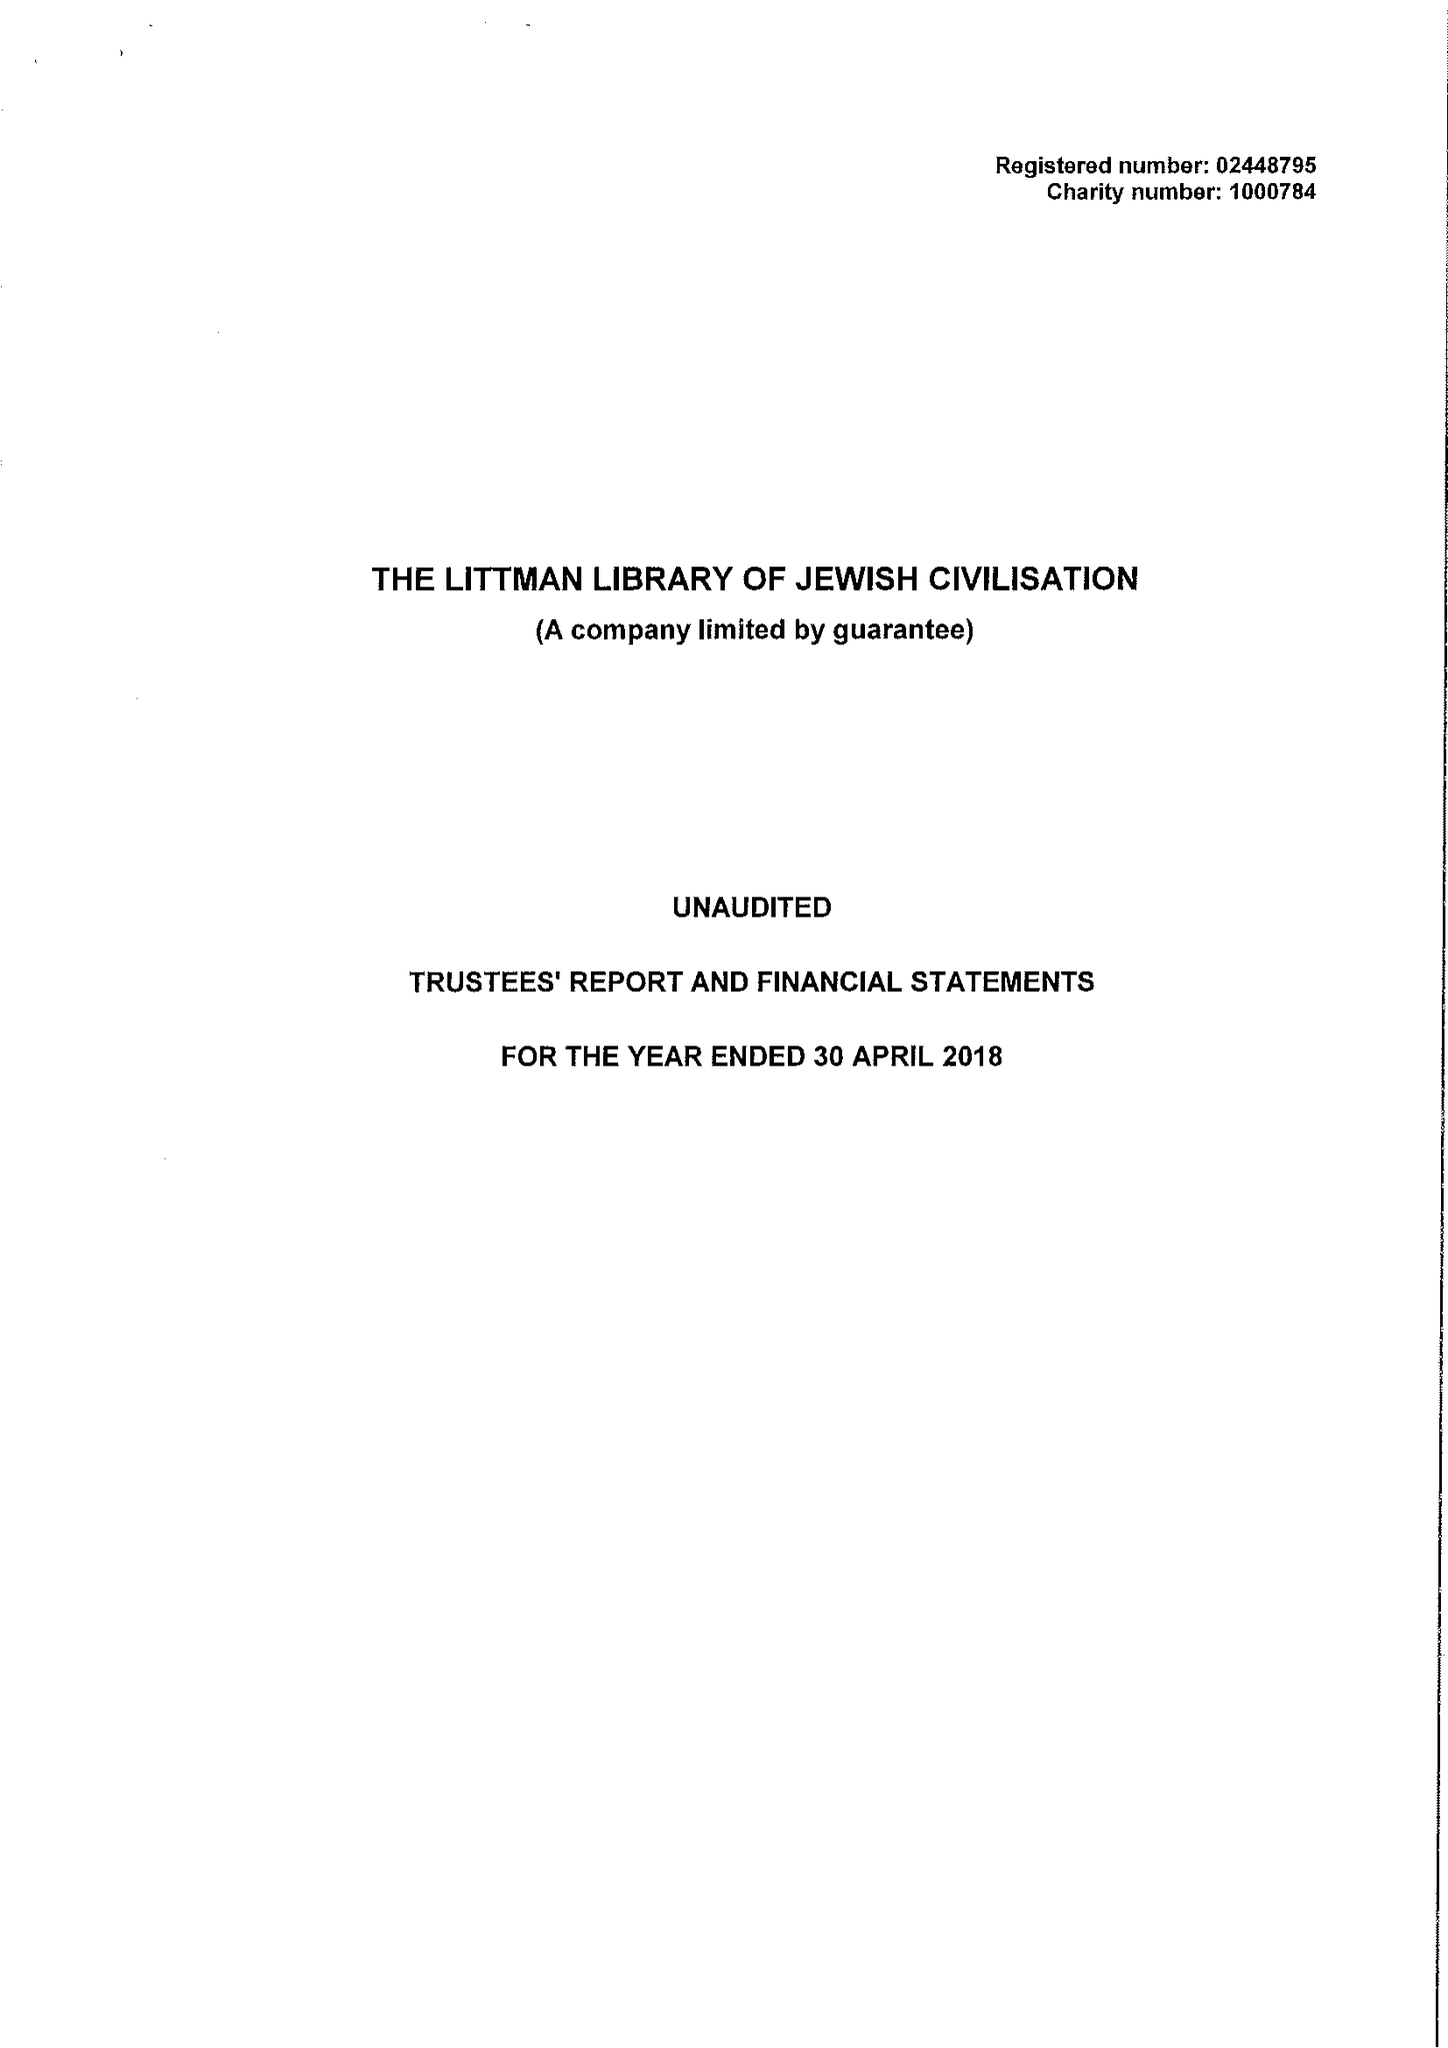What is the value for the report_date?
Answer the question using a single word or phrase. 2018-04-30 